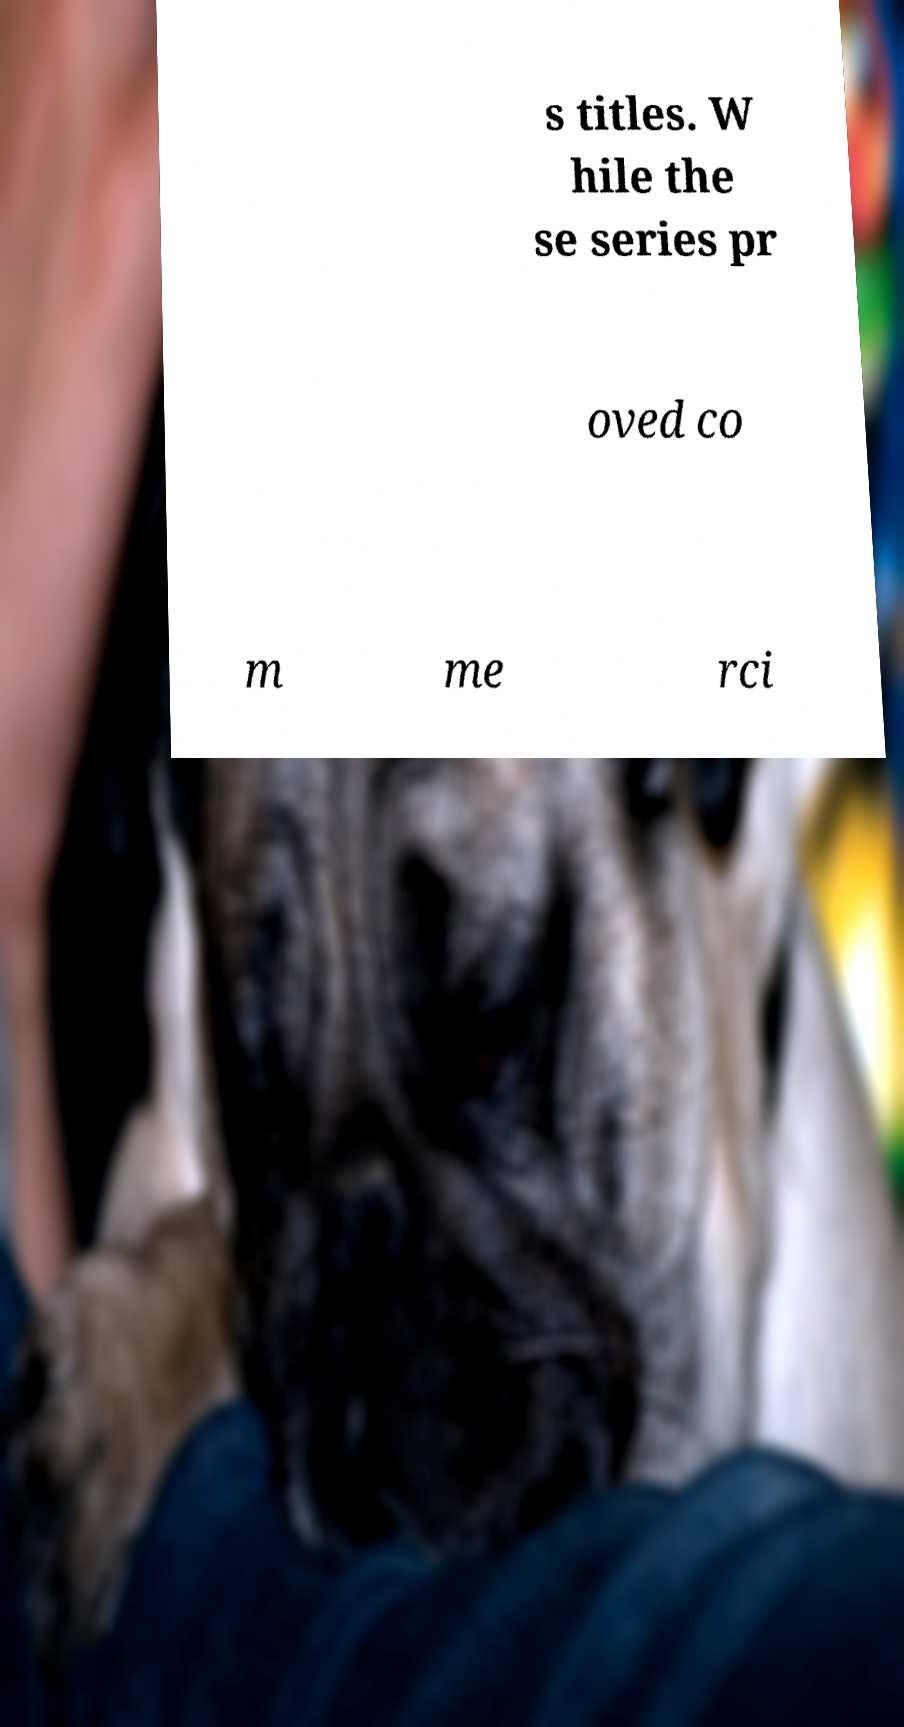Could you extract and type out the text from this image? s titles. W hile the se series pr oved co m me rci 